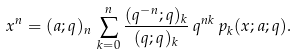<formula> <loc_0><loc_0><loc_500><loc_500>x ^ { n } = ( a ; q ) _ { n } \, \sum _ { k = 0 } ^ { n } \frac { ( q ^ { - n } ; q ) _ { k } } { ( q ; q ) _ { k } } \, q ^ { n k } \, p _ { k } ( x ; a ; q ) .</formula> 